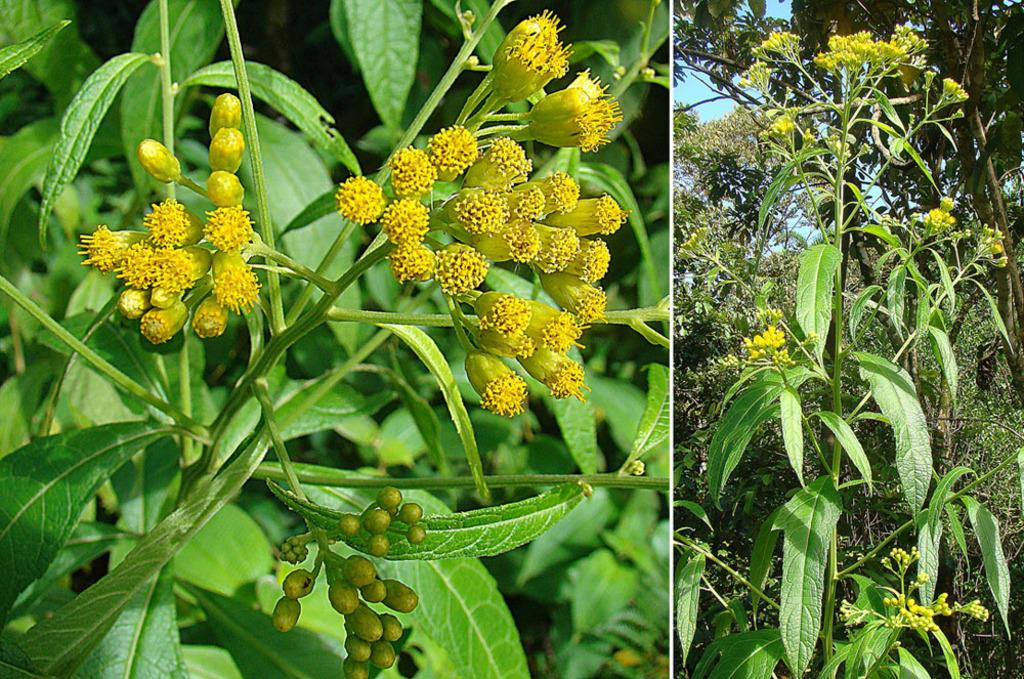What type of artwork is the image? The image is a collage. What type of natural elements can be seen in the image? There are trees, plants, and buds in the image. What part of the natural environment is visible in the image? The sky is visible in the image. What type of skin condition can be seen on the trees in the image? There is no indication of any skin condition on the trees in the image; they appear to be healthy. What type of clouds can be seen in the image? The provided facts do not mention any clouds in the image. 